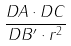<formula> <loc_0><loc_0><loc_500><loc_500>\frac { D A \cdot D C } { D B ^ { \prime } \cdot r ^ { 2 } }</formula> 